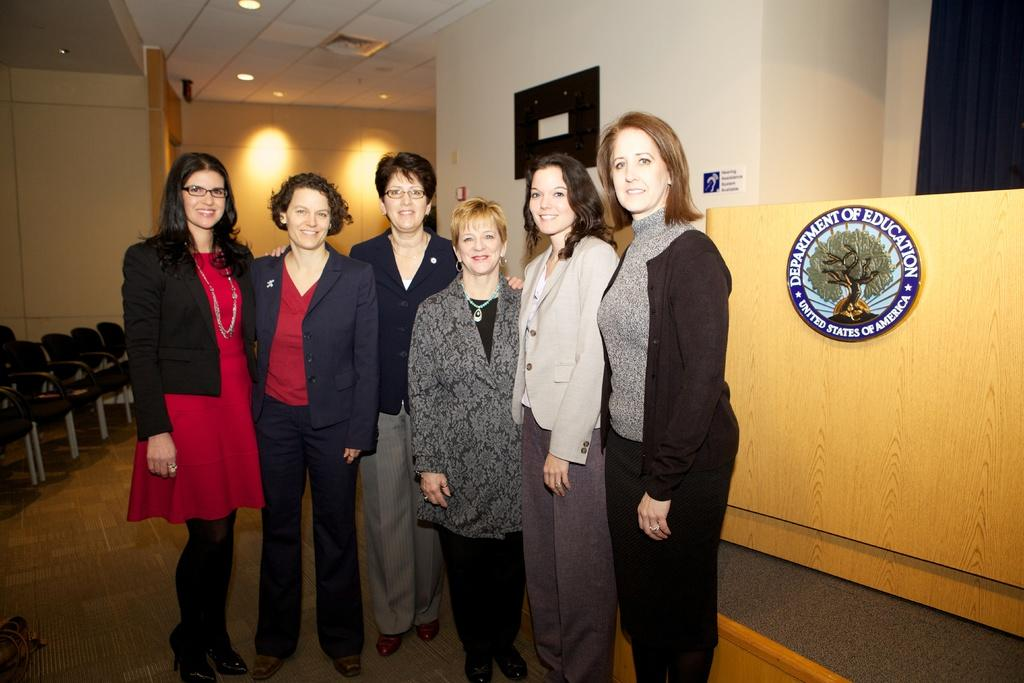What is the main subject of the image? The main subject of the image is a group of women. Where are the women located in the image? The women are standing on the floor in the image. What other objects can be seen in the image? There are chairs, lights, a logo with some text on a wall, and a roof with some ceiling lights in the image. What type of cheese is being served on the sock in the image? There is no sock or cheese present in the image. 